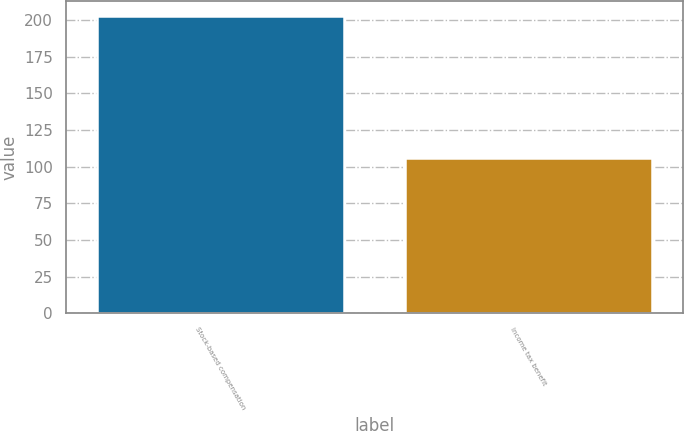Convert chart. <chart><loc_0><loc_0><loc_500><loc_500><bar_chart><fcel>Stock-based compensation<fcel>Income tax benefit<nl><fcel>203<fcel>106<nl></chart> 